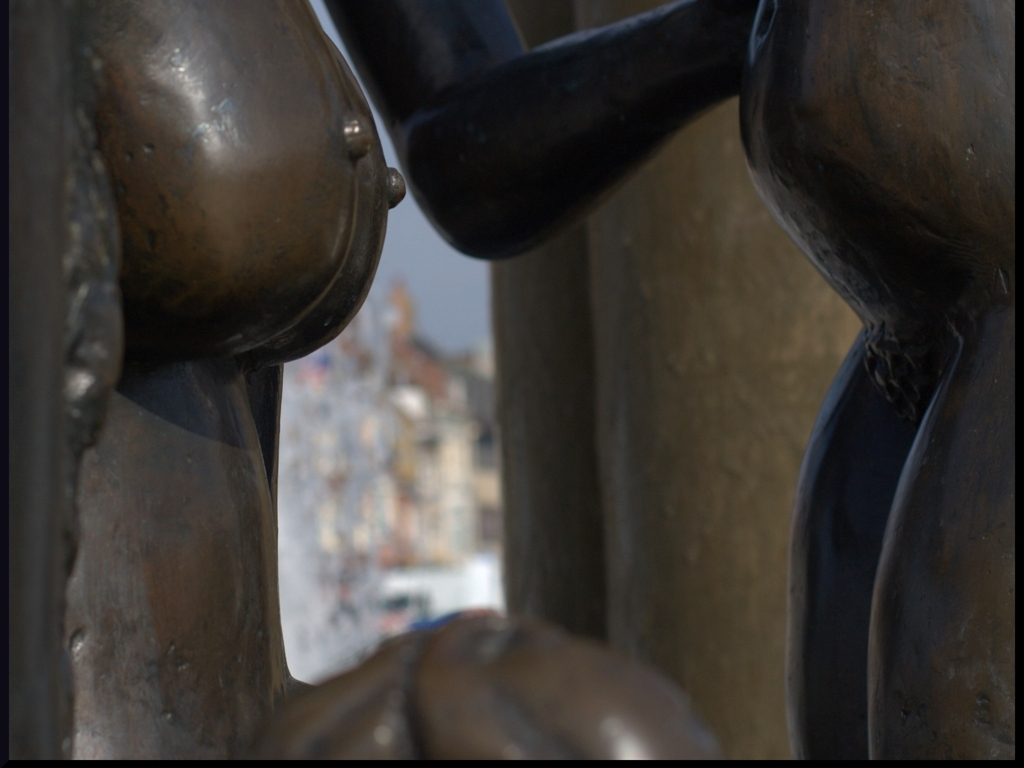Is the lighting of the image good? The lighting in the image provides a dramatic effect, highlighting the contours and reflections on the bronze surface. It brings out the texture and patina of the metal, suggesting a sense of history and age, while the background is softly illuminated to draw attention to the subject in the foreground. 